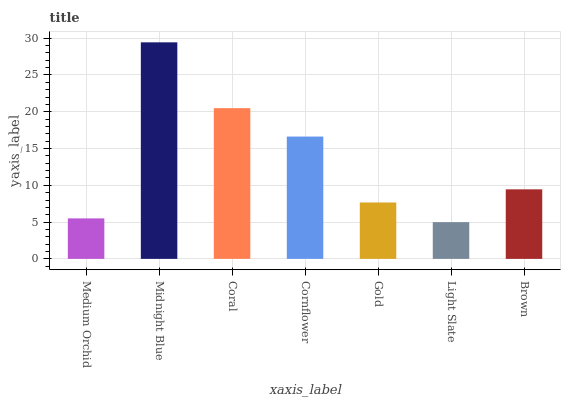Is Light Slate the minimum?
Answer yes or no. Yes. Is Midnight Blue the maximum?
Answer yes or no. Yes. Is Coral the minimum?
Answer yes or no. No. Is Coral the maximum?
Answer yes or no. No. Is Midnight Blue greater than Coral?
Answer yes or no. Yes. Is Coral less than Midnight Blue?
Answer yes or no. Yes. Is Coral greater than Midnight Blue?
Answer yes or no. No. Is Midnight Blue less than Coral?
Answer yes or no. No. Is Brown the high median?
Answer yes or no. Yes. Is Brown the low median?
Answer yes or no. Yes. Is Gold the high median?
Answer yes or no. No. Is Gold the low median?
Answer yes or no. No. 